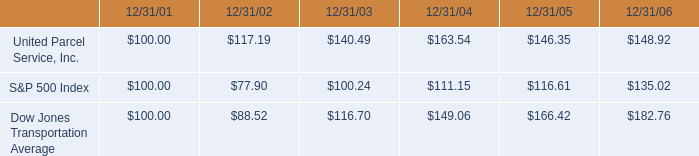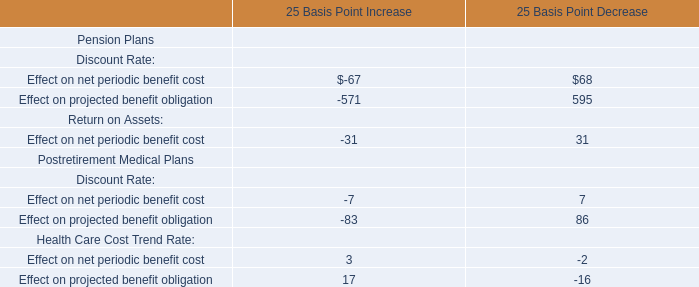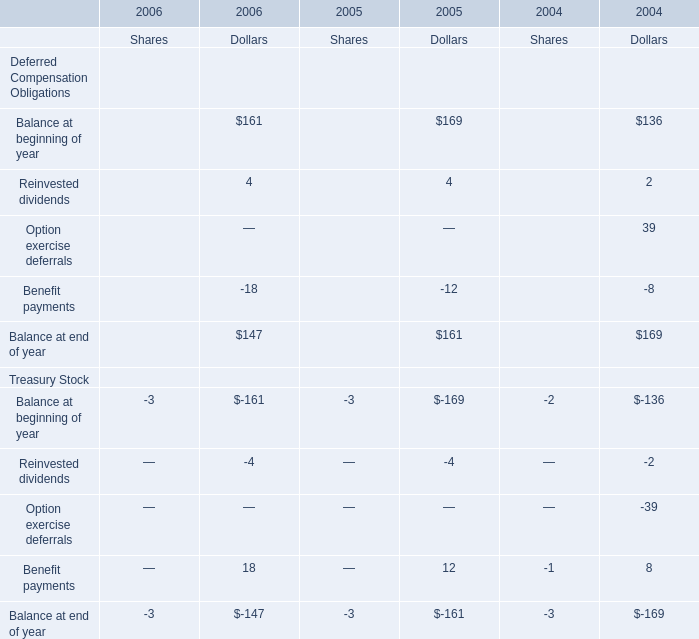What's the growth rate of Dollars for Balance at end of year for Deferred Compensation Obligations in 2006? 
Computations: ((147 - 161) / 161)
Answer: -0.08696. 